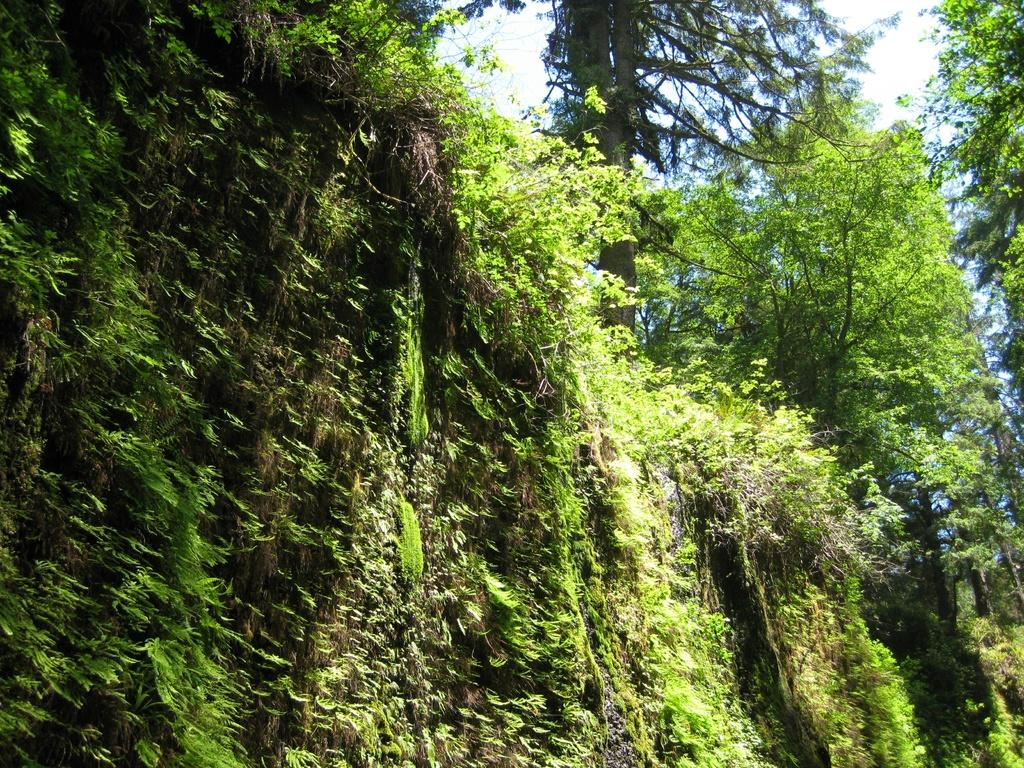What is the dominant color in the image? There is a lot of greenery in the image, so the dominant color is green. What can be seen in the background of the image? The sky is visible in the background of the image. Reasoning: Leting: Let's think step by step in order to produce the conversation. We start by identifying the main feature of the image, which is the greenery. Then, we describe the background of the image, which is the sky. Each question is designed to elicit a specific detail about the image that is known from the provided facts. Absurd Question/Answer: How many cans of paint are used to create the greenery in the image? There is no indication that the greenery in the image is created with paint, so it is not possible to determine the number of cans used. 